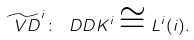<formula> <loc_0><loc_0><loc_500><loc_500>\widetilde { \ V D } ^ { i } \colon \ D D K ^ { i } \cong L ^ { i } ( i ) .</formula> 